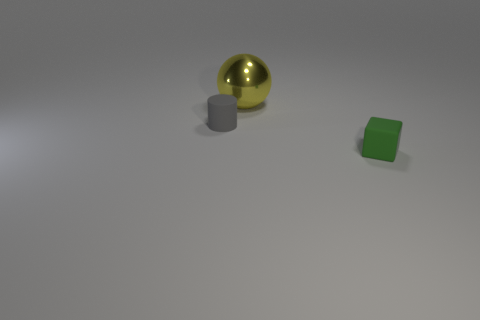Add 2 large cyan matte cubes. How many objects exist? 5 Subtract all blocks. How many objects are left? 2 Add 1 small red matte things. How many small red matte things exist? 1 Subtract 0 yellow cylinders. How many objects are left? 3 Subtract all big metal objects. Subtract all matte cubes. How many objects are left? 1 Add 1 metal objects. How many metal objects are left? 2 